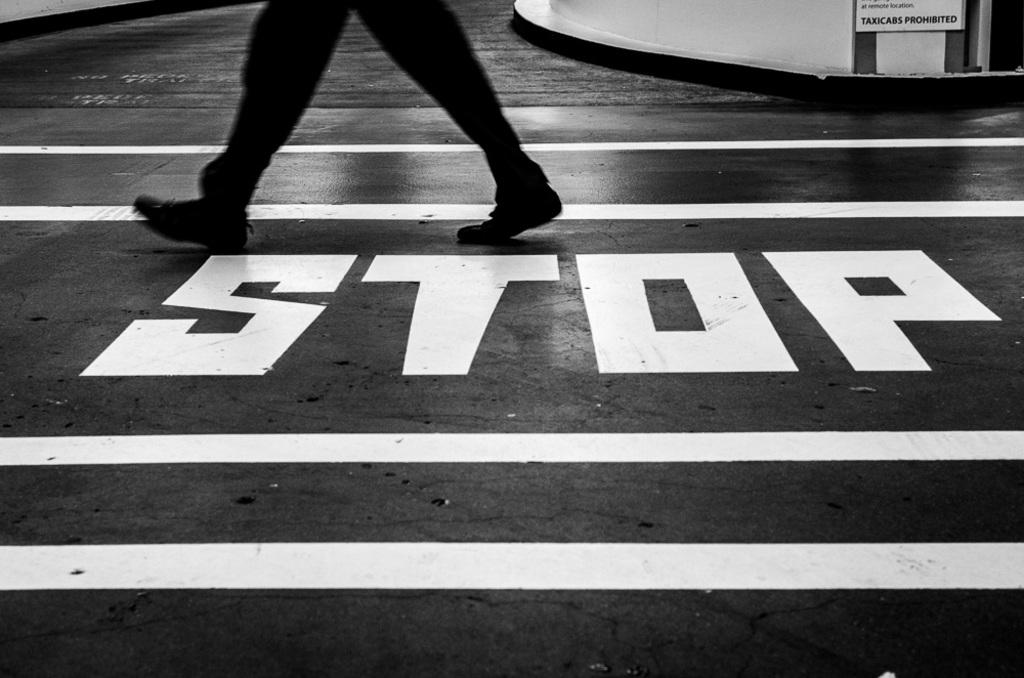What is the color scheme of the image? The image is black and white. What is the person in the image doing? The person is walking in the image. Where is the person walking? The person is walking on a road. What is present in the top right corner of the image? There is a text board in the top right corner of the image. What type of grass can be seen growing on the side of the road in the image? There is no grass visible in the image, as it is black and white and does not show any vegetation. 